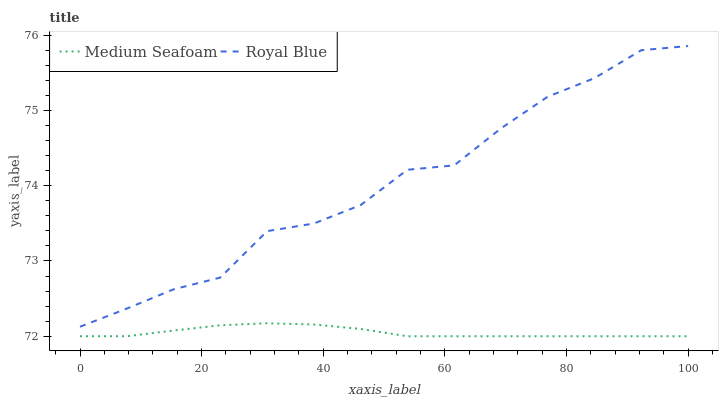Does Medium Seafoam have the minimum area under the curve?
Answer yes or no. Yes. Does Royal Blue have the maximum area under the curve?
Answer yes or no. Yes. Does Medium Seafoam have the maximum area under the curve?
Answer yes or no. No. Is Medium Seafoam the smoothest?
Answer yes or no. Yes. Is Royal Blue the roughest?
Answer yes or no. Yes. Is Medium Seafoam the roughest?
Answer yes or no. No. Does Royal Blue have the highest value?
Answer yes or no. Yes. Does Medium Seafoam have the highest value?
Answer yes or no. No. Is Medium Seafoam less than Royal Blue?
Answer yes or no. Yes. Is Royal Blue greater than Medium Seafoam?
Answer yes or no. Yes. Does Medium Seafoam intersect Royal Blue?
Answer yes or no. No. 